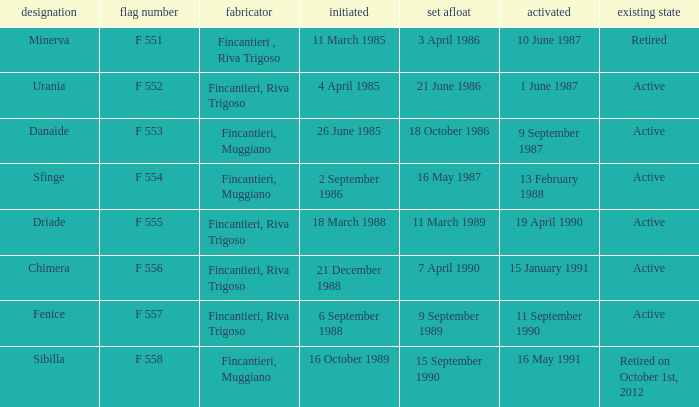What builder is now retired F 551. 